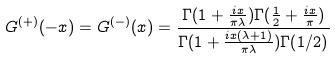<formula> <loc_0><loc_0><loc_500><loc_500>G ^ { ( + ) } ( - x ) = G ^ { ( - ) } ( x ) = \frac { \Gamma ( 1 + \frac { i x } { \pi \lambda } ) \Gamma ( \frac { 1 } { 2 } + \frac { i x } { \pi } ) } { \Gamma ( 1 + \frac { i x ( \lambda + 1 ) } { \pi \lambda } ) \Gamma ( 1 / 2 ) }</formula> 